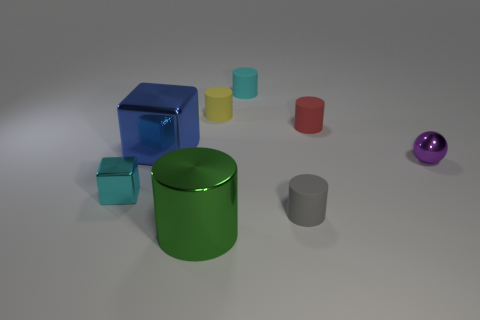How many things are right of the cyan object that is right of the big shiny thing that is behind the gray cylinder?
Offer a terse response. 3. Does the small metallic thing that is to the left of the small gray thing have the same color as the tiny matte object that is behind the yellow matte object?
Ensure brevity in your answer.  Yes. There is a tiny thing that is both behind the big metal cube and right of the small gray cylinder; what is its color?
Provide a succinct answer. Red. What number of green things are the same size as the cyan metallic thing?
Ensure brevity in your answer.  0. There is a small cyan thing behind the small purple object right of the tiny gray cylinder; what shape is it?
Keep it short and to the point. Cylinder. What is the shape of the rubber thing in front of the big blue metal thing in front of the tiny thing that is behind the yellow thing?
Provide a succinct answer. Cylinder. What number of tiny cyan metallic things are the same shape as the large blue object?
Ensure brevity in your answer.  1. How many large shiny things are in front of the tiny matte thing that is in front of the red cylinder?
Your answer should be compact. 1. What number of metal objects are either big green objects or big blue cubes?
Make the answer very short. 2. Is there a tiny cyan thing made of the same material as the tiny gray object?
Give a very brief answer. Yes. 